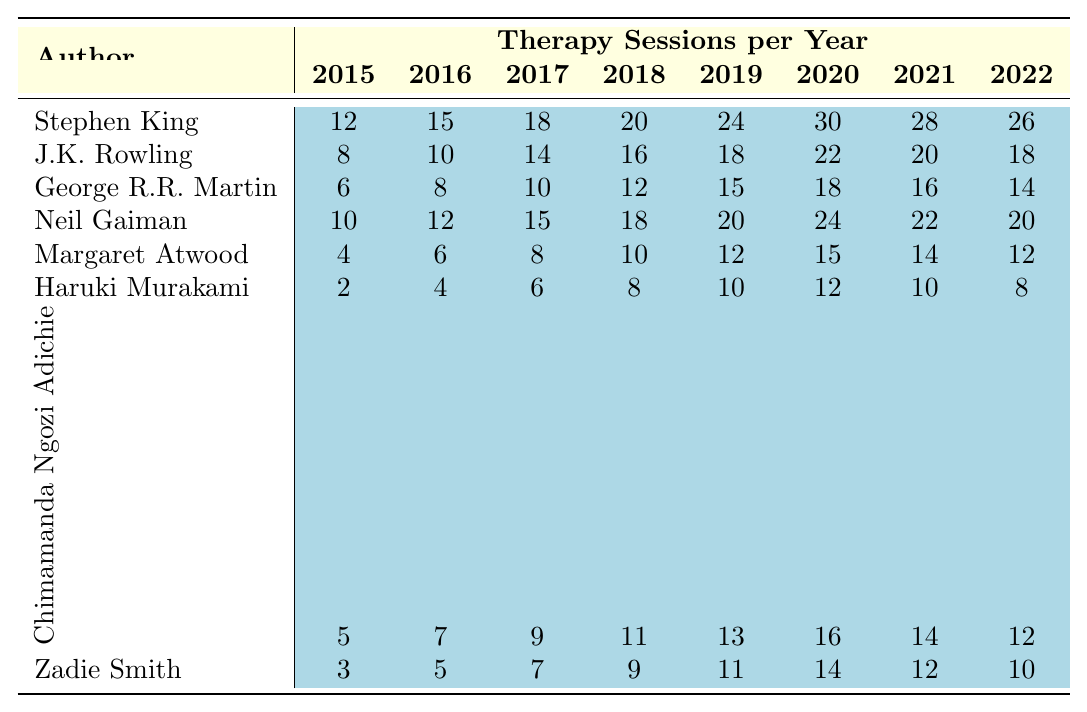What was the highest number of therapy sessions per year for Stephen King? According to the table, Stephen King had a maximum of 30 therapy sessions in the year 2020.
Answer: 30 In which year did J.K. Rowling have the most therapy sessions? The table shows that J.K. Rowling had 22 sessions in 2020, which is her highest number compared to other years listed.
Answer: 2020 What is the average number of therapy sessions per year for Neil Gaiman? To find the average for Neil Gaiman, add the sessions from all years (10 + 12 + 15 + 18 + 20 + 24 + 22 + 20 = 121) and divide by the number of years (121/8 = 15.125).
Answer: 15.125 Did Margaret Atwood ever attend more than 15 therapy sessions in a year? By looking at the table, it's clear that Margaret Atwood's maximum was 15 sessions in 2020, which means she never attended more than that.
Answer: No Which author had the least number of therapy sessions in 2015? In 2015, Haruki Murakami had the fewest sessions with only 2 attended according to the table.
Answer: 2 How much did therapy sessions for George R.R. Martin increase from 2016 to 2020? The sessions increased from 8 in 2016 to 18 in 2020, resulting in an increase of 10 sessions (18 - 8 = 10).
Answer: 10 What was the trend of therapy sessions for Zadie Smith from 2015 to 2022? Zadie Smith's sessions show an increasing trend up to 2019 (3, 5, 7, 9, 11) and then a peak at 14 in 2020, followed by a small decline to 12 in 2021 and 10 in 2022.
Answer: Increasing then decreasing Which author had the highest overall total of therapy sessions over the 8 years? By calculating the total sessions for each author, Stephen King's total is 12+15+18+20+24+30+28+26=153, which is higher than other authors.
Answer: Stephen King What were the therapy session numbers for Haruki Murakami in 2019 and 2020, and what is their difference? Haruki Murakami had 10 sessions in 2019 and 12 sessions in 2020, their difference is 2 (12 - 10 = 2).
Answer: 2 Was there any year in which Chimamanda Ngozi Adichie had fewer therapy sessions than Haruki Murakami? Checking the table, in 2018 and 2021, Chimamanda had 11 and 14 sessions respectively while Haruki had 8 and 10. Therefore, she never had fewer sessions than Haruki.
Answer: No 